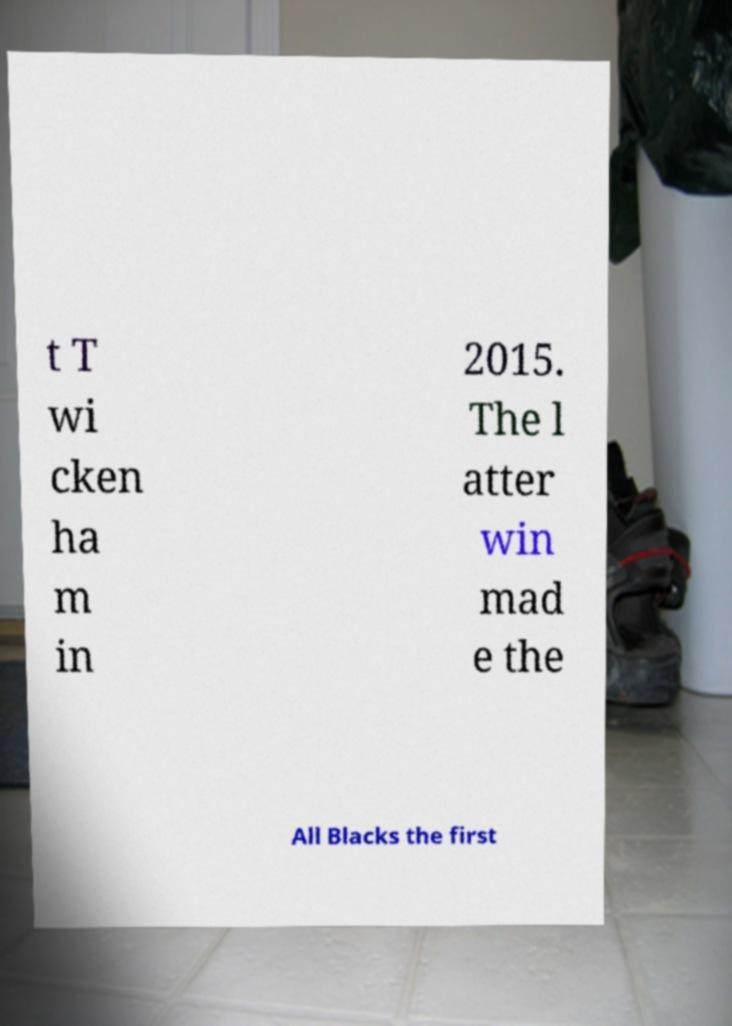There's text embedded in this image that I need extracted. Can you transcribe it verbatim? t T wi cken ha m in 2015. The l atter win mad e the All Blacks the first 